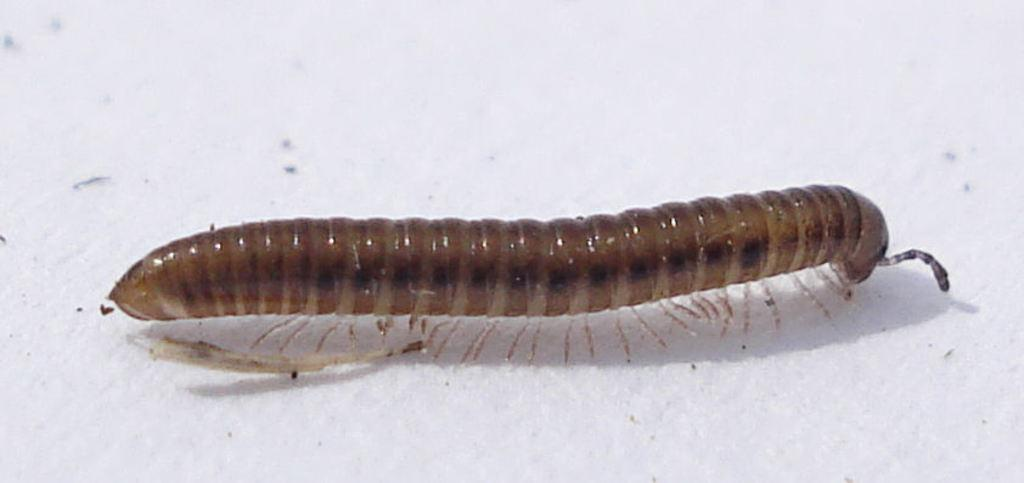What type of creature is present in the image? There is an insect in the image. What is the insect resting on in the image? The insect is on a white surface. What type of steel structure can be seen in the image? There is no steel structure present in the image; it only features an insect on a white surface. 